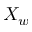<formula> <loc_0><loc_0><loc_500><loc_500>X _ { w }</formula> 